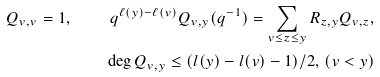Convert formula to latex. <formula><loc_0><loc_0><loc_500><loc_500>Q _ { v , v } = 1 , \quad q ^ { \ell ( y ) - \ell ( v ) } Q _ { v , y } ( q ^ { - 1 } ) = \sum _ { v \leq z \leq y } R _ { z , y } Q _ { v , z } , \\ \deg Q _ { v , y } \leq ( l ( y ) - l ( v ) - 1 ) / 2 , \, ( v < y )</formula> 